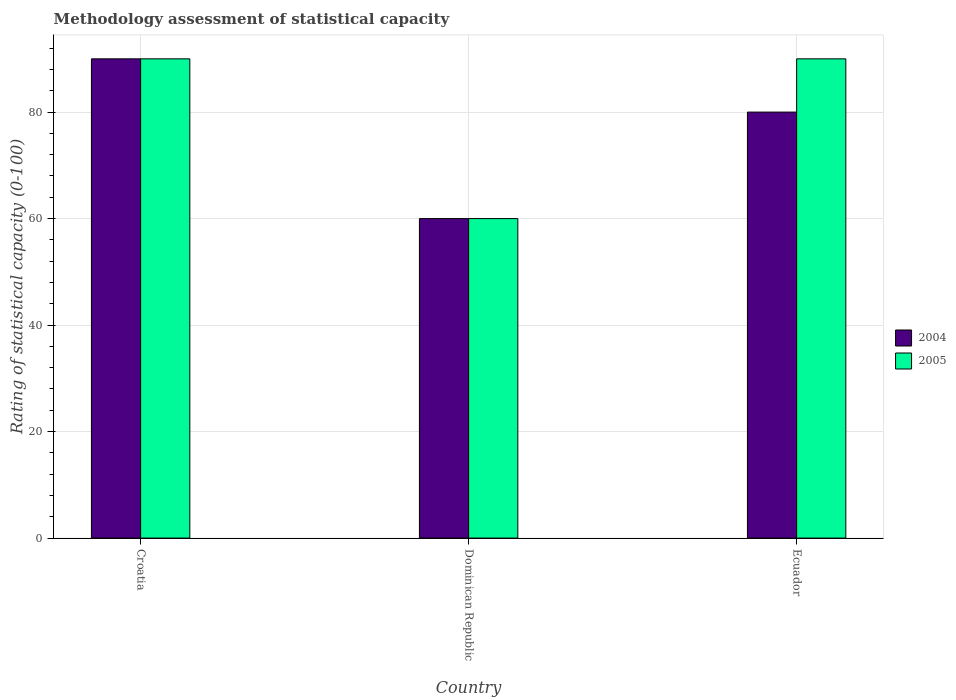How many groups of bars are there?
Provide a succinct answer. 3. Are the number of bars per tick equal to the number of legend labels?
Your response must be concise. Yes. Are the number of bars on each tick of the X-axis equal?
Offer a very short reply. Yes. What is the label of the 2nd group of bars from the left?
Your response must be concise. Dominican Republic. In how many cases, is the number of bars for a given country not equal to the number of legend labels?
Make the answer very short. 0. Across all countries, what is the maximum rating of statistical capacity in 2004?
Give a very brief answer. 90. In which country was the rating of statistical capacity in 2005 maximum?
Keep it short and to the point. Croatia. In which country was the rating of statistical capacity in 2004 minimum?
Give a very brief answer. Dominican Republic. What is the total rating of statistical capacity in 2004 in the graph?
Make the answer very short. 230. What is the difference between the rating of statistical capacity in 2004 in Croatia and that in Ecuador?
Your answer should be compact. 10. Is the rating of statistical capacity in 2004 in Croatia less than that in Dominican Republic?
Your answer should be compact. No. Is the difference between the rating of statistical capacity in 2004 in Croatia and Ecuador greater than the difference between the rating of statistical capacity in 2005 in Croatia and Ecuador?
Give a very brief answer. Yes. What is the difference between the highest and the second highest rating of statistical capacity in 2005?
Provide a succinct answer. 30. What does the 1st bar from the left in Dominican Republic represents?
Offer a very short reply. 2004. How many bars are there?
Make the answer very short. 6. How many countries are there in the graph?
Provide a short and direct response. 3. Does the graph contain grids?
Offer a very short reply. Yes. What is the title of the graph?
Keep it short and to the point. Methodology assessment of statistical capacity. What is the label or title of the X-axis?
Your response must be concise. Country. What is the label or title of the Y-axis?
Your response must be concise. Rating of statistical capacity (0-100). What is the Rating of statistical capacity (0-100) in 2004 in Croatia?
Offer a terse response. 90. What is the Rating of statistical capacity (0-100) of 2004 in Dominican Republic?
Offer a very short reply. 60. What is the Rating of statistical capacity (0-100) in 2005 in Dominican Republic?
Your answer should be compact. 60. What is the Rating of statistical capacity (0-100) in 2005 in Ecuador?
Make the answer very short. 90. Across all countries, what is the maximum Rating of statistical capacity (0-100) in 2004?
Your answer should be compact. 90. Across all countries, what is the maximum Rating of statistical capacity (0-100) in 2005?
Your answer should be compact. 90. What is the total Rating of statistical capacity (0-100) in 2004 in the graph?
Offer a very short reply. 230. What is the total Rating of statistical capacity (0-100) in 2005 in the graph?
Provide a short and direct response. 240. What is the difference between the Rating of statistical capacity (0-100) of 2004 in Croatia and that in Dominican Republic?
Provide a short and direct response. 30. What is the difference between the Rating of statistical capacity (0-100) of 2005 in Croatia and that in Dominican Republic?
Your answer should be compact. 30. What is the difference between the Rating of statistical capacity (0-100) of 2004 in Croatia and that in Ecuador?
Provide a succinct answer. 10. What is the difference between the Rating of statistical capacity (0-100) in 2005 in Croatia and that in Ecuador?
Make the answer very short. 0. What is the difference between the Rating of statistical capacity (0-100) in 2004 in Dominican Republic and that in Ecuador?
Give a very brief answer. -20. What is the difference between the Rating of statistical capacity (0-100) in 2004 in Dominican Republic and the Rating of statistical capacity (0-100) in 2005 in Ecuador?
Offer a very short reply. -30. What is the average Rating of statistical capacity (0-100) of 2004 per country?
Provide a succinct answer. 76.67. What is the average Rating of statistical capacity (0-100) in 2005 per country?
Provide a succinct answer. 80. What is the difference between the Rating of statistical capacity (0-100) of 2004 and Rating of statistical capacity (0-100) of 2005 in Croatia?
Keep it short and to the point. 0. What is the ratio of the Rating of statistical capacity (0-100) of 2005 in Croatia to that in Dominican Republic?
Give a very brief answer. 1.5. What is the ratio of the Rating of statistical capacity (0-100) of 2004 in Croatia to that in Ecuador?
Provide a short and direct response. 1.12. What is the ratio of the Rating of statistical capacity (0-100) in 2005 in Croatia to that in Ecuador?
Keep it short and to the point. 1. What is the ratio of the Rating of statistical capacity (0-100) in 2004 in Dominican Republic to that in Ecuador?
Your response must be concise. 0.75. What is the ratio of the Rating of statistical capacity (0-100) of 2005 in Dominican Republic to that in Ecuador?
Offer a very short reply. 0.67. 